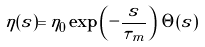Convert formula to latex. <formula><loc_0><loc_0><loc_500><loc_500>\eta ( s ) = \eta _ { 0 } \exp \left ( - \frac { s } { \tau _ { m } } \right ) \, \Theta ( s )</formula> 